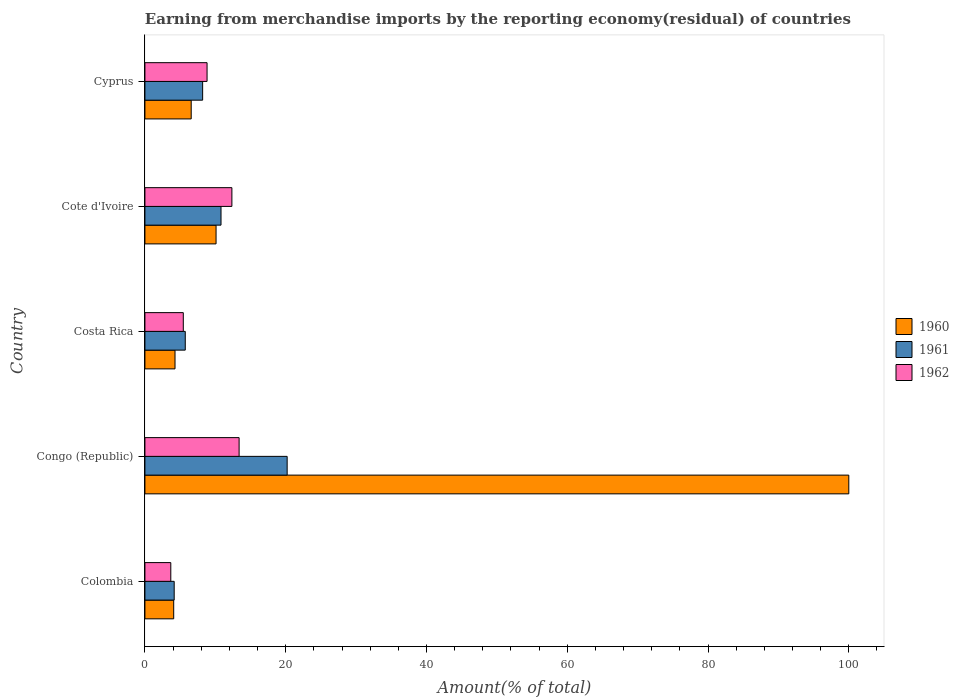How many groups of bars are there?
Ensure brevity in your answer.  5. Are the number of bars per tick equal to the number of legend labels?
Your answer should be very brief. Yes. How many bars are there on the 3rd tick from the bottom?
Provide a succinct answer. 3. What is the label of the 4th group of bars from the top?
Your answer should be very brief. Congo (Republic). What is the percentage of amount earned from merchandise imports in 1962 in Congo (Republic)?
Your answer should be compact. 13.38. Across all countries, what is the maximum percentage of amount earned from merchandise imports in 1961?
Offer a terse response. 20.21. Across all countries, what is the minimum percentage of amount earned from merchandise imports in 1962?
Make the answer very short. 3.68. In which country was the percentage of amount earned from merchandise imports in 1962 maximum?
Provide a succinct answer. Congo (Republic). In which country was the percentage of amount earned from merchandise imports in 1960 minimum?
Offer a very short reply. Colombia. What is the total percentage of amount earned from merchandise imports in 1960 in the graph?
Offer a terse response. 125.05. What is the difference between the percentage of amount earned from merchandise imports in 1962 in Costa Rica and that in Cote d'Ivoire?
Provide a short and direct response. -6.9. What is the difference between the percentage of amount earned from merchandise imports in 1960 in Cote d'Ivoire and the percentage of amount earned from merchandise imports in 1962 in Colombia?
Your answer should be compact. 6.43. What is the average percentage of amount earned from merchandise imports in 1961 per country?
Give a very brief answer. 9.82. What is the difference between the percentage of amount earned from merchandise imports in 1961 and percentage of amount earned from merchandise imports in 1962 in Cyprus?
Your response must be concise. -0.63. What is the ratio of the percentage of amount earned from merchandise imports in 1962 in Colombia to that in Cyprus?
Provide a succinct answer. 0.42. Is the percentage of amount earned from merchandise imports in 1960 in Cote d'Ivoire less than that in Cyprus?
Provide a short and direct response. No. Is the difference between the percentage of amount earned from merchandise imports in 1961 in Colombia and Cyprus greater than the difference between the percentage of amount earned from merchandise imports in 1962 in Colombia and Cyprus?
Give a very brief answer. Yes. What is the difference between the highest and the second highest percentage of amount earned from merchandise imports in 1962?
Ensure brevity in your answer.  1.03. What is the difference between the highest and the lowest percentage of amount earned from merchandise imports in 1962?
Provide a short and direct response. 9.71. In how many countries, is the percentage of amount earned from merchandise imports in 1960 greater than the average percentage of amount earned from merchandise imports in 1960 taken over all countries?
Make the answer very short. 1. Is the sum of the percentage of amount earned from merchandise imports in 1962 in Colombia and Costa Rica greater than the maximum percentage of amount earned from merchandise imports in 1961 across all countries?
Your response must be concise. No. What does the 3rd bar from the top in Costa Rica represents?
Your answer should be compact. 1960. Is it the case that in every country, the sum of the percentage of amount earned from merchandise imports in 1962 and percentage of amount earned from merchandise imports in 1961 is greater than the percentage of amount earned from merchandise imports in 1960?
Offer a very short reply. No. Are all the bars in the graph horizontal?
Provide a short and direct response. Yes. What is the difference between two consecutive major ticks on the X-axis?
Keep it short and to the point. 20. Are the values on the major ticks of X-axis written in scientific E-notation?
Offer a terse response. No. Does the graph contain grids?
Give a very brief answer. No. How many legend labels are there?
Offer a very short reply. 3. How are the legend labels stacked?
Your answer should be compact. Vertical. What is the title of the graph?
Your answer should be compact. Earning from merchandise imports by the reporting economy(residual) of countries. What is the label or title of the X-axis?
Provide a succinct answer. Amount(% of total). What is the Amount(% of total) in 1960 in Colombia?
Offer a terse response. 4.09. What is the Amount(% of total) of 1961 in Colombia?
Your answer should be very brief. 4.16. What is the Amount(% of total) of 1962 in Colombia?
Your answer should be compact. 3.68. What is the Amount(% of total) in 1961 in Congo (Republic)?
Provide a short and direct response. 20.21. What is the Amount(% of total) of 1962 in Congo (Republic)?
Ensure brevity in your answer.  13.38. What is the Amount(% of total) of 1960 in Costa Rica?
Keep it short and to the point. 4.28. What is the Amount(% of total) of 1961 in Costa Rica?
Your answer should be very brief. 5.73. What is the Amount(% of total) of 1962 in Costa Rica?
Your answer should be compact. 5.45. What is the Amount(% of total) of 1960 in Cote d'Ivoire?
Keep it short and to the point. 10.11. What is the Amount(% of total) of 1961 in Cote d'Ivoire?
Your answer should be very brief. 10.81. What is the Amount(% of total) in 1962 in Cote d'Ivoire?
Give a very brief answer. 12.36. What is the Amount(% of total) of 1960 in Cyprus?
Your answer should be very brief. 6.58. What is the Amount(% of total) of 1961 in Cyprus?
Ensure brevity in your answer.  8.2. What is the Amount(% of total) in 1962 in Cyprus?
Provide a short and direct response. 8.83. Across all countries, what is the maximum Amount(% of total) of 1960?
Offer a very short reply. 100. Across all countries, what is the maximum Amount(% of total) in 1961?
Your response must be concise. 20.21. Across all countries, what is the maximum Amount(% of total) of 1962?
Ensure brevity in your answer.  13.38. Across all countries, what is the minimum Amount(% of total) in 1960?
Provide a succinct answer. 4.09. Across all countries, what is the minimum Amount(% of total) in 1961?
Your response must be concise. 4.16. Across all countries, what is the minimum Amount(% of total) in 1962?
Provide a succinct answer. 3.68. What is the total Amount(% of total) of 1960 in the graph?
Offer a terse response. 125.05. What is the total Amount(% of total) in 1961 in the graph?
Give a very brief answer. 49.11. What is the total Amount(% of total) in 1962 in the graph?
Offer a terse response. 43.69. What is the difference between the Amount(% of total) of 1960 in Colombia and that in Congo (Republic)?
Your response must be concise. -95.91. What is the difference between the Amount(% of total) in 1961 in Colombia and that in Congo (Republic)?
Give a very brief answer. -16.05. What is the difference between the Amount(% of total) in 1962 in Colombia and that in Congo (Republic)?
Your response must be concise. -9.71. What is the difference between the Amount(% of total) of 1960 in Colombia and that in Costa Rica?
Offer a terse response. -0.19. What is the difference between the Amount(% of total) of 1961 in Colombia and that in Costa Rica?
Your answer should be very brief. -1.57. What is the difference between the Amount(% of total) in 1962 in Colombia and that in Costa Rica?
Keep it short and to the point. -1.78. What is the difference between the Amount(% of total) in 1960 in Colombia and that in Cote d'Ivoire?
Provide a succinct answer. -6.02. What is the difference between the Amount(% of total) of 1961 in Colombia and that in Cote d'Ivoire?
Your response must be concise. -6.65. What is the difference between the Amount(% of total) in 1962 in Colombia and that in Cote d'Ivoire?
Provide a succinct answer. -8.68. What is the difference between the Amount(% of total) of 1960 in Colombia and that in Cyprus?
Make the answer very short. -2.48. What is the difference between the Amount(% of total) in 1961 in Colombia and that in Cyprus?
Your response must be concise. -4.04. What is the difference between the Amount(% of total) of 1962 in Colombia and that in Cyprus?
Make the answer very short. -5.15. What is the difference between the Amount(% of total) of 1960 in Congo (Republic) and that in Costa Rica?
Offer a terse response. 95.72. What is the difference between the Amount(% of total) in 1961 in Congo (Republic) and that in Costa Rica?
Provide a short and direct response. 14.47. What is the difference between the Amount(% of total) in 1962 in Congo (Republic) and that in Costa Rica?
Keep it short and to the point. 7.93. What is the difference between the Amount(% of total) of 1960 in Congo (Republic) and that in Cote d'Ivoire?
Your answer should be compact. 89.89. What is the difference between the Amount(% of total) of 1961 in Congo (Republic) and that in Cote d'Ivoire?
Give a very brief answer. 9.4. What is the difference between the Amount(% of total) in 1962 in Congo (Republic) and that in Cote d'Ivoire?
Provide a succinct answer. 1.03. What is the difference between the Amount(% of total) of 1960 in Congo (Republic) and that in Cyprus?
Provide a short and direct response. 93.42. What is the difference between the Amount(% of total) in 1961 in Congo (Republic) and that in Cyprus?
Your answer should be compact. 12.01. What is the difference between the Amount(% of total) in 1962 in Congo (Republic) and that in Cyprus?
Your answer should be very brief. 4.55. What is the difference between the Amount(% of total) in 1960 in Costa Rica and that in Cote d'Ivoire?
Keep it short and to the point. -5.83. What is the difference between the Amount(% of total) in 1961 in Costa Rica and that in Cote d'Ivoire?
Your response must be concise. -5.08. What is the difference between the Amount(% of total) of 1962 in Costa Rica and that in Cote d'Ivoire?
Provide a short and direct response. -6.9. What is the difference between the Amount(% of total) of 1960 in Costa Rica and that in Cyprus?
Make the answer very short. -2.3. What is the difference between the Amount(% of total) in 1961 in Costa Rica and that in Cyprus?
Your response must be concise. -2.47. What is the difference between the Amount(% of total) of 1962 in Costa Rica and that in Cyprus?
Give a very brief answer. -3.38. What is the difference between the Amount(% of total) of 1960 in Cote d'Ivoire and that in Cyprus?
Offer a very short reply. 3.53. What is the difference between the Amount(% of total) of 1961 in Cote d'Ivoire and that in Cyprus?
Offer a very short reply. 2.61. What is the difference between the Amount(% of total) of 1962 in Cote d'Ivoire and that in Cyprus?
Your response must be concise. 3.53. What is the difference between the Amount(% of total) in 1960 in Colombia and the Amount(% of total) in 1961 in Congo (Republic)?
Offer a very short reply. -16.12. What is the difference between the Amount(% of total) in 1960 in Colombia and the Amount(% of total) in 1962 in Congo (Republic)?
Your response must be concise. -9.29. What is the difference between the Amount(% of total) in 1961 in Colombia and the Amount(% of total) in 1962 in Congo (Republic)?
Keep it short and to the point. -9.22. What is the difference between the Amount(% of total) of 1960 in Colombia and the Amount(% of total) of 1961 in Costa Rica?
Your answer should be very brief. -1.64. What is the difference between the Amount(% of total) in 1960 in Colombia and the Amount(% of total) in 1962 in Costa Rica?
Offer a terse response. -1.36. What is the difference between the Amount(% of total) of 1961 in Colombia and the Amount(% of total) of 1962 in Costa Rica?
Make the answer very short. -1.29. What is the difference between the Amount(% of total) of 1960 in Colombia and the Amount(% of total) of 1961 in Cote d'Ivoire?
Offer a very short reply. -6.72. What is the difference between the Amount(% of total) in 1960 in Colombia and the Amount(% of total) in 1962 in Cote d'Ivoire?
Offer a very short reply. -8.27. What is the difference between the Amount(% of total) of 1961 in Colombia and the Amount(% of total) of 1962 in Cote d'Ivoire?
Provide a succinct answer. -8.2. What is the difference between the Amount(% of total) of 1960 in Colombia and the Amount(% of total) of 1961 in Cyprus?
Your response must be concise. -4.11. What is the difference between the Amount(% of total) in 1960 in Colombia and the Amount(% of total) in 1962 in Cyprus?
Provide a succinct answer. -4.74. What is the difference between the Amount(% of total) of 1961 in Colombia and the Amount(% of total) of 1962 in Cyprus?
Offer a very short reply. -4.67. What is the difference between the Amount(% of total) of 1960 in Congo (Republic) and the Amount(% of total) of 1961 in Costa Rica?
Ensure brevity in your answer.  94.27. What is the difference between the Amount(% of total) in 1960 in Congo (Republic) and the Amount(% of total) in 1962 in Costa Rica?
Your answer should be very brief. 94.55. What is the difference between the Amount(% of total) of 1961 in Congo (Republic) and the Amount(% of total) of 1962 in Costa Rica?
Provide a succinct answer. 14.76. What is the difference between the Amount(% of total) in 1960 in Congo (Republic) and the Amount(% of total) in 1961 in Cote d'Ivoire?
Keep it short and to the point. 89.19. What is the difference between the Amount(% of total) in 1960 in Congo (Republic) and the Amount(% of total) in 1962 in Cote d'Ivoire?
Your response must be concise. 87.64. What is the difference between the Amount(% of total) of 1961 in Congo (Republic) and the Amount(% of total) of 1962 in Cote d'Ivoire?
Offer a very short reply. 7.85. What is the difference between the Amount(% of total) of 1960 in Congo (Republic) and the Amount(% of total) of 1961 in Cyprus?
Offer a very short reply. 91.8. What is the difference between the Amount(% of total) in 1960 in Congo (Republic) and the Amount(% of total) in 1962 in Cyprus?
Offer a terse response. 91.17. What is the difference between the Amount(% of total) of 1961 in Congo (Republic) and the Amount(% of total) of 1962 in Cyprus?
Make the answer very short. 11.38. What is the difference between the Amount(% of total) of 1960 in Costa Rica and the Amount(% of total) of 1961 in Cote d'Ivoire?
Your response must be concise. -6.53. What is the difference between the Amount(% of total) of 1960 in Costa Rica and the Amount(% of total) of 1962 in Cote d'Ivoire?
Your response must be concise. -8.08. What is the difference between the Amount(% of total) in 1961 in Costa Rica and the Amount(% of total) in 1962 in Cote d'Ivoire?
Your answer should be compact. -6.62. What is the difference between the Amount(% of total) in 1960 in Costa Rica and the Amount(% of total) in 1961 in Cyprus?
Give a very brief answer. -3.92. What is the difference between the Amount(% of total) in 1960 in Costa Rica and the Amount(% of total) in 1962 in Cyprus?
Offer a terse response. -4.55. What is the difference between the Amount(% of total) of 1961 in Costa Rica and the Amount(% of total) of 1962 in Cyprus?
Give a very brief answer. -3.1. What is the difference between the Amount(% of total) of 1960 in Cote d'Ivoire and the Amount(% of total) of 1961 in Cyprus?
Your answer should be very brief. 1.91. What is the difference between the Amount(% of total) of 1960 in Cote d'Ivoire and the Amount(% of total) of 1962 in Cyprus?
Provide a short and direct response. 1.28. What is the difference between the Amount(% of total) in 1961 in Cote d'Ivoire and the Amount(% of total) in 1962 in Cyprus?
Your answer should be very brief. 1.98. What is the average Amount(% of total) in 1960 per country?
Your answer should be very brief. 25.01. What is the average Amount(% of total) of 1961 per country?
Ensure brevity in your answer.  9.82. What is the average Amount(% of total) of 1962 per country?
Offer a terse response. 8.74. What is the difference between the Amount(% of total) of 1960 and Amount(% of total) of 1961 in Colombia?
Provide a short and direct response. -0.07. What is the difference between the Amount(% of total) of 1960 and Amount(% of total) of 1962 in Colombia?
Your answer should be very brief. 0.41. What is the difference between the Amount(% of total) of 1961 and Amount(% of total) of 1962 in Colombia?
Your answer should be compact. 0.48. What is the difference between the Amount(% of total) of 1960 and Amount(% of total) of 1961 in Congo (Republic)?
Your response must be concise. 79.79. What is the difference between the Amount(% of total) of 1960 and Amount(% of total) of 1962 in Congo (Republic)?
Your answer should be very brief. 86.62. What is the difference between the Amount(% of total) in 1961 and Amount(% of total) in 1962 in Congo (Republic)?
Ensure brevity in your answer.  6.83. What is the difference between the Amount(% of total) in 1960 and Amount(% of total) in 1961 in Costa Rica?
Provide a short and direct response. -1.46. What is the difference between the Amount(% of total) in 1960 and Amount(% of total) in 1962 in Costa Rica?
Make the answer very short. -1.17. What is the difference between the Amount(% of total) in 1961 and Amount(% of total) in 1962 in Costa Rica?
Ensure brevity in your answer.  0.28. What is the difference between the Amount(% of total) of 1960 and Amount(% of total) of 1961 in Cote d'Ivoire?
Offer a terse response. -0.7. What is the difference between the Amount(% of total) in 1960 and Amount(% of total) in 1962 in Cote d'Ivoire?
Offer a very short reply. -2.25. What is the difference between the Amount(% of total) in 1961 and Amount(% of total) in 1962 in Cote d'Ivoire?
Your answer should be compact. -1.55. What is the difference between the Amount(% of total) in 1960 and Amount(% of total) in 1961 in Cyprus?
Offer a terse response. -1.62. What is the difference between the Amount(% of total) in 1960 and Amount(% of total) in 1962 in Cyprus?
Provide a short and direct response. -2.25. What is the difference between the Amount(% of total) in 1961 and Amount(% of total) in 1962 in Cyprus?
Offer a terse response. -0.63. What is the ratio of the Amount(% of total) of 1960 in Colombia to that in Congo (Republic)?
Offer a very short reply. 0.04. What is the ratio of the Amount(% of total) in 1961 in Colombia to that in Congo (Republic)?
Offer a terse response. 0.21. What is the ratio of the Amount(% of total) of 1962 in Colombia to that in Congo (Republic)?
Your answer should be compact. 0.27. What is the ratio of the Amount(% of total) in 1960 in Colombia to that in Costa Rica?
Your response must be concise. 0.96. What is the ratio of the Amount(% of total) of 1961 in Colombia to that in Costa Rica?
Your answer should be very brief. 0.73. What is the ratio of the Amount(% of total) in 1962 in Colombia to that in Costa Rica?
Your answer should be compact. 0.67. What is the ratio of the Amount(% of total) in 1960 in Colombia to that in Cote d'Ivoire?
Your answer should be compact. 0.4. What is the ratio of the Amount(% of total) of 1961 in Colombia to that in Cote d'Ivoire?
Ensure brevity in your answer.  0.38. What is the ratio of the Amount(% of total) in 1962 in Colombia to that in Cote d'Ivoire?
Your answer should be compact. 0.3. What is the ratio of the Amount(% of total) of 1960 in Colombia to that in Cyprus?
Your answer should be very brief. 0.62. What is the ratio of the Amount(% of total) in 1961 in Colombia to that in Cyprus?
Ensure brevity in your answer.  0.51. What is the ratio of the Amount(% of total) in 1962 in Colombia to that in Cyprus?
Ensure brevity in your answer.  0.42. What is the ratio of the Amount(% of total) in 1960 in Congo (Republic) to that in Costa Rica?
Keep it short and to the point. 23.38. What is the ratio of the Amount(% of total) of 1961 in Congo (Republic) to that in Costa Rica?
Provide a short and direct response. 3.52. What is the ratio of the Amount(% of total) in 1962 in Congo (Republic) to that in Costa Rica?
Make the answer very short. 2.45. What is the ratio of the Amount(% of total) in 1960 in Congo (Republic) to that in Cote d'Ivoire?
Your response must be concise. 9.89. What is the ratio of the Amount(% of total) of 1961 in Congo (Republic) to that in Cote d'Ivoire?
Offer a very short reply. 1.87. What is the ratio of the Amount(% of total) in 1962 in Congo (Republic) to that in Cote d'Ivoire?
Your response must be concise. 1.08. What is the ratio of the Amount(% of total) in 1960 in Congo (Republic) to that in Cyprus?
Ensure brevity in your answer.  15.21. What is the ratio of the Amount(% of total) of 1961 in Congo (Republic) to that in Cyprus?
Provide a short and direct response. 2.46. What is the ratio of the Amount(% of total) of 1962 in Congo (Republic) to that in Cyprus?
Your response must be concise. 1.52. What is the ratio of the Amount(% of total) in 1960 in Costa Rica to that in Cote d'Ivoire?
Your answer should be compact. 0.42. What is the ratio of the Amount(% of total) in 1961 in Costa Rica to that in Cote d'Ivoire?
Your answer should be very brief. 0.53. What is the ratio of the Amount(% of total) of 1962 in Costa Rica to that in Cote d'Ivoire?
Your answer should be compact. 0.44. What is the ratio of the Amount(% of total) in 1960 in Costa Rica to that in Cyprus?
Provide a short and direct response. 0.65. What is the ratio of the Amount(% of total) in 1961 in Costa Rica to that in Cyprus?
Provide a succinct answer. 0.7. What is the ratio of the Amount(% of total) of 1962 in Costa Rica to that in Cyprus?
Offer a terse response. 0.62. What is the ratio of the Amount(% of total) in 1960 in Cote d'Ivoire to that in Cyprus?
Keep it short and to the point. 1.54. What is the ratio of the Amount(% of total) of 1961 in Cote d'Ivoire to that in Cyprus?
Your answer should be very brief. 1.32. What is the ratio of the Amount(% of total) in 1962 in Cote d'Ivoire to that in Cyprus?
Provide a succinct answer. 1.4. What is the difference between the highest and the second highest Amount(% of total) in 1960?
Give a very brief answer. 89.89. What is the difference between the highest and the second highest Amount(% of total) of 1961?
Make the answer very short. 9.4. What is the difference between the highest and the second highest Amount(% of total) of 1962?
Your answer should be compact. 1.03. What is the difference between the highest and the lowest Amount(% of total) of 1960?
Provide a succinct answer. 95.91. What is the difference between the highest and the lowest Amount(% of total) in 1961?
Keep it short and to the point. 16.05. What is the difference between the highest and the lowest Amount(% of total) of 1962?
Offer a terse response. 9.71. 